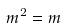<formula> <loc_0><loc_0><loc_500><loc_500>m ^ { 2 } = m</formula> 